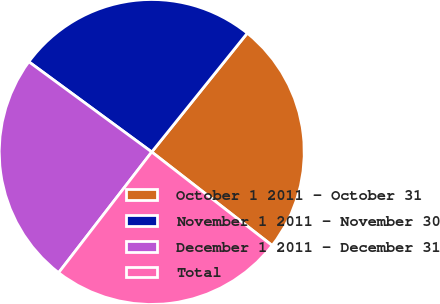Convert chart to OTSL. <chart><loc_0><loc_0><loc_500><loc_500><pie_chart><fcel>October 1 2011 - October 31<fcel>November 1 2011 - November 30<fcel>December 1 2011 - December 31<fcel>Total<nl><fcel>24.73%<fcel>25.7%<fcel>24.62%<fcel>24.95%<nl></chart> 